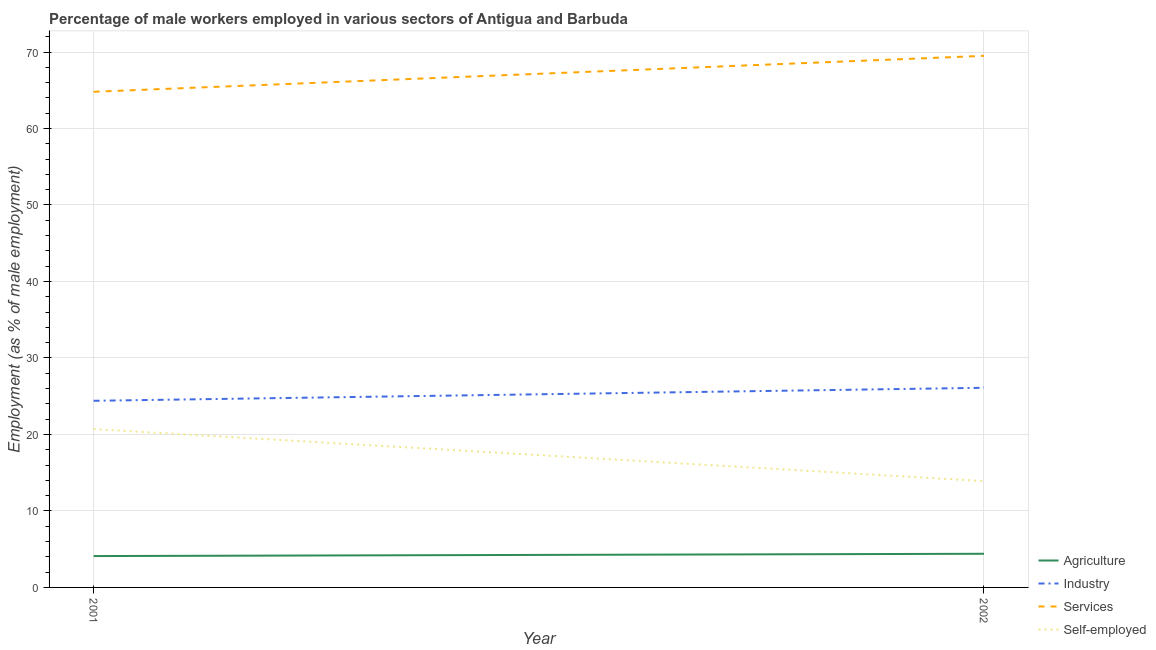Does the line corresponding to percentage of male workers in agriculture intersect with the line corresponding to percentage of male workers in services?
Give a very brief answer. No. Is the number of lines equal to the number of legend labels?
Ensure brevity in your answer.  Yes. What is the percentage of male workers in services in 2001?
Ensure brevity in your answer.  64.8. Across all years, what is the maximum percentage of male workers in agriculture?
Give a very brief answer. 4.4. Across all years, what is the minimum percentage of male workers in agriculture?
Offer a very short reply. 4.1. What is the total percentage of male workers in services in the graph?
Provide a succinct answer. 134.3. What is the difference between the percentage of male workers in services in 2001 and that in 2002?
Offer a terse response. -4.7. What is the difference between the percentage of male workers in services in 2002 and the percentage of male workers in industry in 2001?
Provide a short and direct response. 45.1. What is the average percentage of male workers in services per year?
Your answer should be very brief. 67.15. In the year 2002, what is the difference between the percentage of male workers in services and percentage of male workers in agriculture?
Give a very brief answer. 65.1. In how many years, is the percentage of male workers in services greater than 64 %?
Your answer should be compact. 2. What is the ratio of the percentage of male workers in services in 2001 to that in 2002?
Make the answer very short. 0.93. Is the percentage of male workers in industry in 2001 less than that in 2002?
Give a very brief answer. Yes. In how many years, is the percentage of male workers in services greater than the average percentage of male workers in services taken over all years?
Offer a very short reply. 1. Is it the case that in every year, the sum of the percentage of male workers in services and percentage of self employed male workers is greater than the sum of percentage of male workers in agriculture and percentage of male workers in industry?
Keep it short and to the point. Yes. Is it the case that in every year, the sum of the percentage of male workers in agriculture and percentage of male workers in industry is greater than the percentage of male workers in services?
Ensure brevity in your answer.  No. Does the percentage of male workers in services monotonically increase over the years?
Your answer should be compact. Yes. How many lines are there?
Ensure brevity in your answer.  4. How many years are there in the graph?
Provide a succinct answer. 2. Does the graph contain any zero values?
Give a very brief answer. No. Where does the legend appear in the graph?
Your response must be concise. Bottom right. How many legend labels are there?
Your answer should be very brief. 4. How are the legend labels stacked?
Ensure brevity in your answer.  Vertical. What is the title of the graph?
Your answer should be compact. Percentage of male workers employed in various sectors of Antigua and Barbuda. Does "Agriculture" appear as one of the legend labels in the graph?
Keep it short and to the point. Yes. What is the label or title of the X-axis?
Give a very brief answer. Year. What is the label or title of the Y-axis?
Offer a very short reply. Employment (as % of male employment). What is the Employment (as % of male employment) of Agriculture in 2001?
Your answer should be compact. 4.1. What is the Employment (as % of male employment) in Industry in 2001?
Give a very brief answer. 24.4. What is the Employment (as % of male employment) of Services in 2001?
Offer a very short reply. 64.8. What is the Employment (as % of male employment) of Self-employed in 2001?
Give a very brief answer. 20.7. What is the Employment (as % of male employment) of Agriculture in 2002?
Your answer should be very brief. 4.4. What is the Employment (as % of male employment) in Industry in 2002?
Your response must be concise. 26.1. What is the Employment (as % of male employment) in Services in 2002?
Your answer should be compact. 69.5. What is the Employment (as % of male employment) in Self-employed in 2002?
Provide a short and direct response. 13.9. Across all years, what is the maximum Employment (as % of male employment) of Agriculture?
Your response must be concise. 4.4. Across all years, what is the maximum Employment (as % of male employment) in Industry?
Make the answer very short. 26.1. Across all years, what is the maximum Employment (as % of male employment) of Services?
Ensure brevity in your answer.  69.5. Across all years, what is the maximum Employment (as % of male employment) in Self-employed?
Make the answer very short. 20.7. Across all years, what is the minimum Employment (as % of male employment) of Agriculture?
Provide a short and direct response. 4.1. Across all years, what is the minimum Employment (as % of male employment) in Industry?
Give a very brief answer. 24.4. Across all years, what is the minimum Employment (as % of male employment) of Services?
Your answer should be compact. 64.8. Across all years, what is the minimum Employment (as % of male employment) of Self-employed?
Offer a very short reply. 13.9. What is the total Employment (as % of male employment) in Industry in the graph?
Provide a short and direct response. 50.5. What is the total Employment (as % of male employment) of Services in the graph?
Your answer should be very brief. 134.3. What is the total Employment (as % of male employment) of Self-employed in the graph?
Keep it short and to the point. 34.6. What is the difference between the Employment (as % of male employment) in Agriculture in 2001 and that in 2002?
Keep it short and to the point. -0.3. What is the difference between the Employment (as % of male employment) of Industry in 2001 and that in 2002?
Offer a very short reply. -1.7. What is the difference between the Employment (as % of male employment) in Agriculture in 2001 and the Employment (as % of male employment) in Services in 2002?
Your response must be concise. -65.4. What is the difference between the Employment (as % of male employment) in Agriculture in 2001 and the Employment (as % of male employment) in Self-employed in 2002?
Ensure brevity in your answer.  -9.8. What is the difference between the Employment (as % of male employment) of Industry in 2001 and the Employment (as % of male employment) of Services in 2002?
Provide a short and direct response. -45.1. What is the difference between the Employment (as % of male employment) of Industry in 2001 and the Employment (as % of male employment) of Self-employed in 2002?
Give a very brief answer. 10.5. What is the difference between the Employment (as % of male employment) of Services in 2001 and the Employment (as % of male employment) of Self-employed in 2002?
Give a very brief answer. 50.9. What is the average Employment (as % of male employment) in Agriculture per year?
Offer a terse response. 4.25. What is the average Employment (as % of male employment) of Industry per year?
Offer a terse response. 25.25. What is the average Employment (as % of male employment) in Services per year?
Give a very brief answer. 67.15. What is the average Employment (as % of male employment) of Self-employed per year?
Keep it short and to the point. 17.3. In the year 2001, what is the difference between the Employment (as % of male employment) of Agriculture and Employment (as % of male employment) of Industry?
Ensure brevity in your answer.  -20.3. In the year 2001, what is the difference between the Employment (as % of male employment) of Agriculture and Employment (as % of male employment) of Services?
Make the answer very short. -60.7. In the year 2001, what is the difference between the Employment (as % of male employment) in Agriculture and Employment (as % of male employment) in Self-employed?
Your response must be concise. -16.6. In the year 2001, what is the difference between the Employment (as % of male employment) in Industry and Employment (as % of male employment) in Services?
Make the answer very short. -40.4. In the year 2001, what is the difference between the Employment (as % of male employment) of Services and Employment (as % of male employment) of Self-employed?
Ensure brevity in your answer.  44.1. In the year 2002, what is the difference between the Employment (as % of male employment) in Agriculture and Employment (as % of male employment) in Industry?
Your answer should be compact. -21.7. In the year 2002, what is the difference between the Employment (as % of male employment) of Agriculture and Employment (as % of male employment) of Services?
Provide a succinct answer. -65.1. In the year 2002, what is the difference between the Employment (as % of male employment) of Industry and Employment (as % of male employment) of Services?
Offer a terse response. -43.4. In the year 2002, what is the difference between the Employment (as % of male employment) in Services and Employment (as % of male employment) in Self-employed?
Offer a very short reply. 55.6. What is the ratio of the Employment (as % of male employment) in Agriculture in 2001 to that in 2002?
Make the answer very short. 0.93. What is the ratio of the Employment (as % of male employment) of Industry in 2001 to that in 2002?
Offer a very short reply. 0.93. What is the ratio of the Employment (as % of male employment) of Services in 2001 to that in 2002?
Offer a terse response. 0.93. What is the ratio of the Employment (as % of male employment) of Self-employed in 2001 to that in 2002?
Give a very brief answer. 1.49. What is the difference between the highest and the second highest Employment (as % of male employment) of Agriculture?
Make the answer very short. 0.3. What is the difference between the highest and the lowest Employment (as % of male employment) of Self-employed?
Your response must be concise. 6.8. 